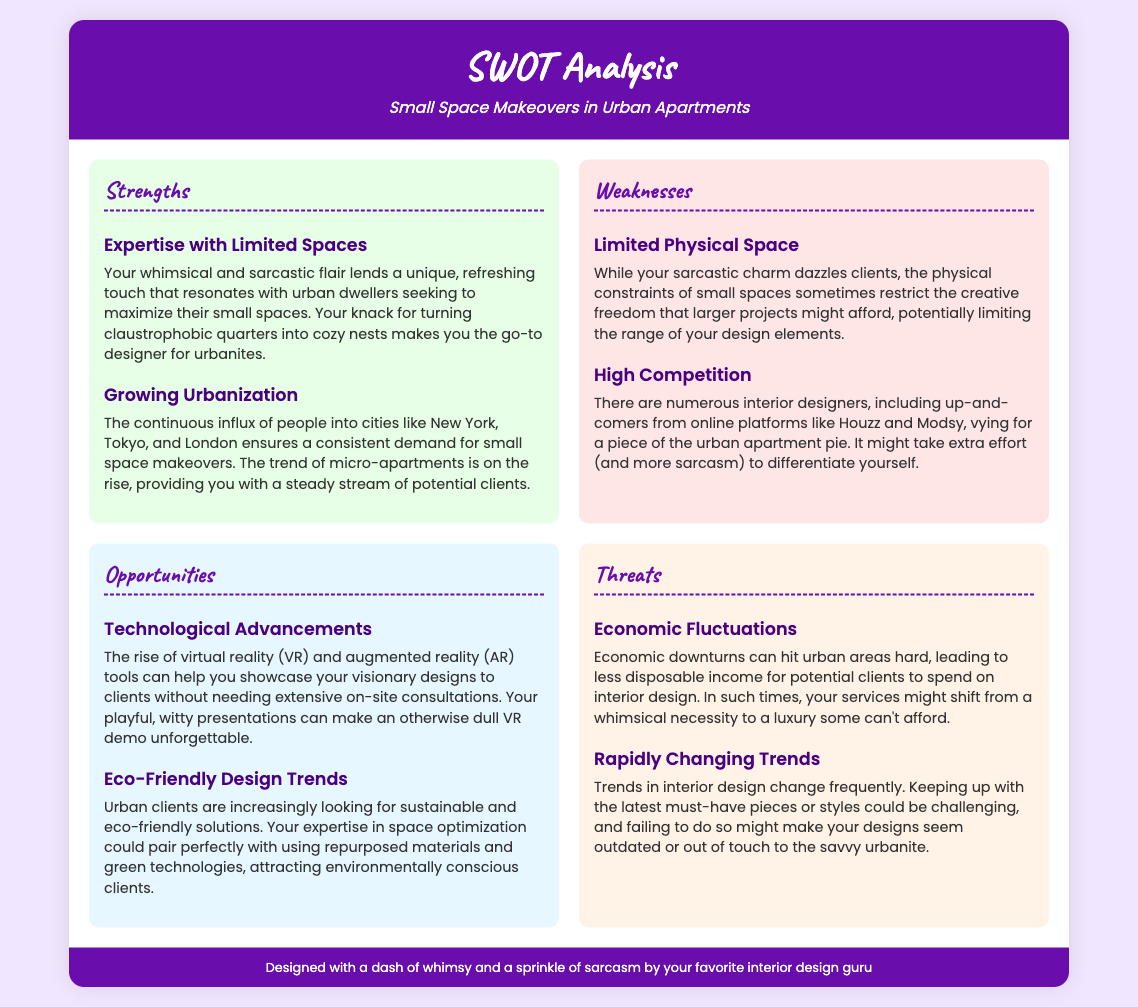what is the title of the document? The title is prominently displayed in the header of the document.
Answer: SWOT Analysis who is the target market for the small space makeovers? The target market is mentioned in the strengths section as urban dwellers.
Answer: Urban dwellers how many strengths are listed in the SWOT analysis? The strengths section contains two distinct items.
Answer: Two what technological trend is mentioned as an opportunity? The specific technological trend is detailed under the opportunities section.
Answer: Virtual reality and augmented reality which economic factor is highlighted as a threat? The economic factor is clearly stated in the threats section.
Answer: Economic fluctuations what is one weakness related to designer competition? This weakness is outlined in the weaknesses section, referring to the competitive landscape.
Answer: High competition what type of design trend is clients are increasingly looking for? This trend is described under the opportunities section, emphasizing modern client preferences.
Answer: Eco-friendly design trends which city is mentioned as part of the growing urbanization trend? The city is referenced in the context of urbanization within the strengths section.
Answer: New York how many opportunities are identified in the SWOT analysis? The opportunities section contains two suggested items for expanding the business.
Answer: Two 